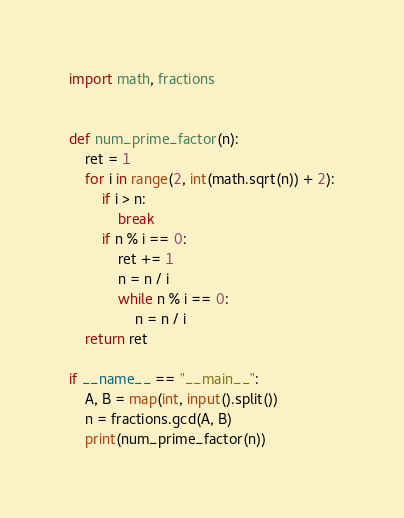<code> <loc_0><loc_0><loc_500><loc_500><_Python_>import math, fractions


def num_prime_factor(n):
    ret = 1
    for i in range(2, int(math.sqrt(n)) + 2):
        if i > n:
            break
        if n % i == 0:
            ret += 1
            n = n / i
            while n % i == 0:
                n = n / i
    return ret

if __name__ == "__main__":
    A, B = map(int, input().split())
    n = fractions.gcd(A, B)
    print(num_prime_factor(n))</code> 